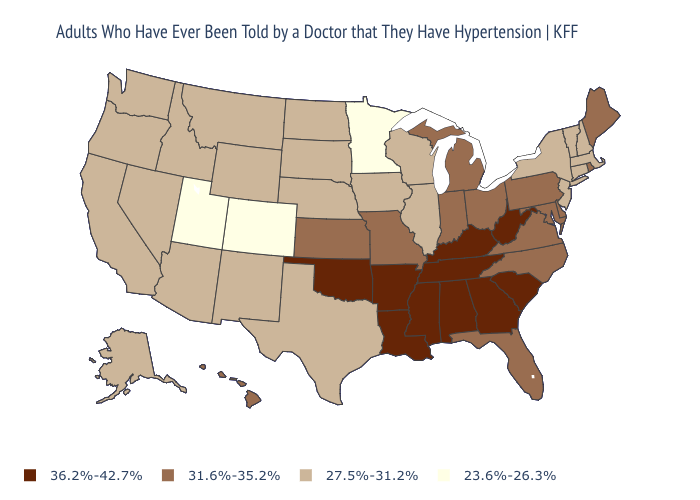Does Vermont have the lowest value in the USA?
Give a very brief answer. No. What is the lowest value in the Northeast?
Be succinct. 27.5%-31.2%. Among the states that border Maine , which have the lowest value?
Keep it brief. New Hampshire. What is the highest value in the USA?
Keep it brief. 36.2%-42.7%. What is the value of Wisconsin?
Give a very brief answer. 27.5%-31.2%. How many symbols are there in the legend?
Short answer required. 4. What is the value of South Carolina?
Give a very brief answer. 36.2%-42.7%. What is the value of Maryland?
Give a very brief answer. 31.6%-35.2%. What is the lowest value in the USA?
Write a very short answer. 23.6%-26.3%. What is the value of Alabama?
Keep it brief. 36.2%-42.7%. What is the highest value in states that border North Dakota?
Give a very brief answer. 27.5%-31.2%. Name the states that have a value in the range 36.2%-42.7%?
Keep it brief. Alabama, Arkansas, Georgia, Kentucky, Louisiana, Mississippi, Oklahoma, South Carolina, Tennessee, West Virginia. What is the lowest value in the USA?
Give a very brief answer. 23.6%-26.3%. What is the value of Maryland?
Quick response, please. 31.6%-35.2%. What is the lowest value in the USA?
Keep it brief. 23.6%-26.3%. 